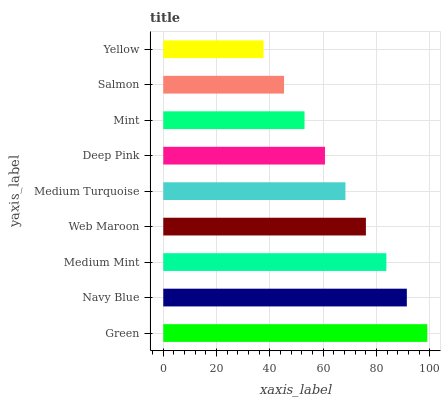Is Yellow the minimum?
Answer yes or no. Yes. Is Green the maximum?
Answer yes or no. Yes. Is Navy Blue the minimum?
Answer yes or no. No. Is Navy Blue the maximum?
Answer yes or no. No. Is Green greater than Navy Blue?
Answer yes or no. Yes. Is Navy Blue less than Green?
Answer yes or no. Yes. Is Navy Blue greater than Green?
Answer yes or no. No. Is Green less than Navy Blue?
Answer yes or no. No. Is Medium Turquoise the high median?
Answer yes or no. Yes. Is Medium Turquoise the low median?
Answer yes or no. Yes. Is Web Maroon the high median?
Answer yes or no. No. Is Deep Pink the low median?
Answer yes or no. No. 